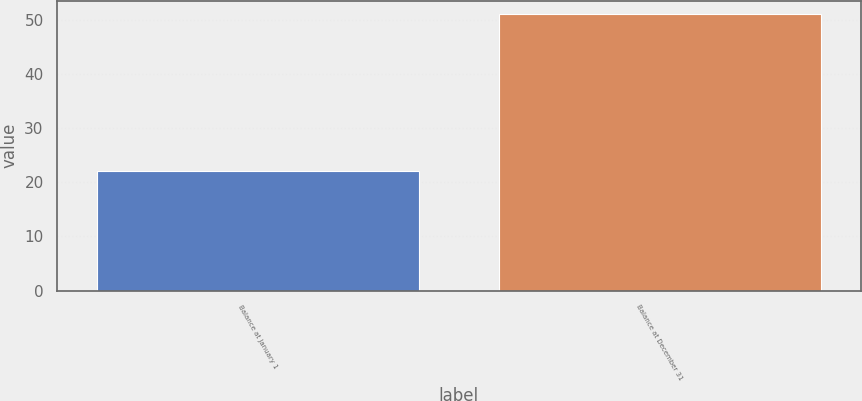Convert chart. <chart><loc_0><loc_0><loc_500><loc_500><bar_chart><fcel>Balance at January 1<fcel>Balance at December 31<nl><fcel>22<fcel>51<nl></chart> 